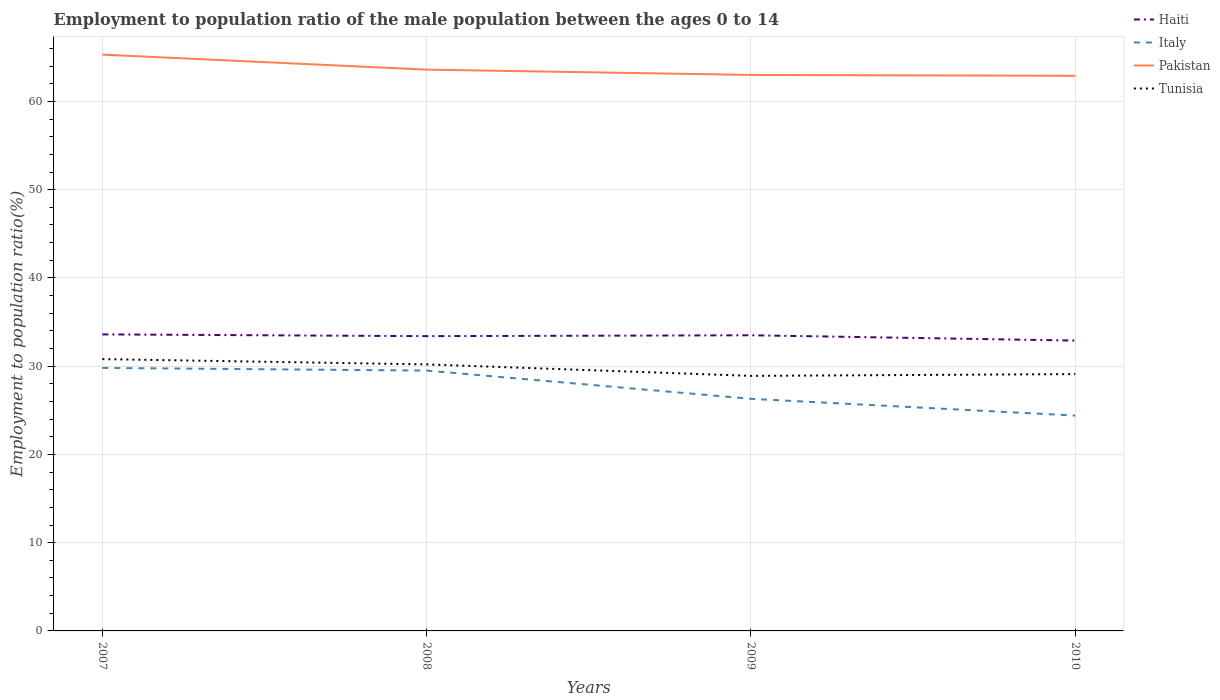Is the number of lines equal to the number of legend labels?
Your answer should be compact. Yes. Across all years, what is the maximum employment to population ratio in Tunisia?
Keep it short and to the point. 28.9. In which year was the employment to population ratio in Tunisia maximum?
Make the answer very short. 2009. What is the total employment to population ratio in Haiti in the graph?
Your answer should be compact. 0.7. What is the difference between the highest and the second highest employment to population ratio in Italy?
Give a very brief answer. 5.4. What is the difference between the highest and the lowest employment to population ratio in Haiti?
Your response must be concise. 3. Is the employment to population ratio in Italy strictly greater than the employment to population ratio in Haiti over the years?
Offer a very short reply. Yes. How many lines are there?
Your answer should be very brief. 4. Does the graph contain any zero values?
Offer a terse response. No. Does the graph contain grids?
Offer a very short reply. Yes. Where does the legend appear in the graph?
Keep it short and to the point. Top right. How many legend labels are there?
Give a very brief answer. 4. What is the title of the graph?
Keep it short and to the point. Employment to population ratio of the male population between the ages 0 to 14. Does "Venezuela" appear as one of the legend labels in the graph?
Your response must be concise. No. What is the Employment to population ratio(%) of Haiti in 2007?
Your response must be concise. 33.6. What is the Employment to population ratio(%) of Italy in 2007?
Keep it short and to the point. 29.8. What is the Employment to population ratio(%) of Pakistan in 2007?
Your response must be concise. 65.3. What is the Employment to population ratio(%) in Tunisia in 2007?
Offer a terse response. 30.8. What is the Employment to population ratio(%) of Haiti in 2008?
Your answer should be compact. 33.4. What is the Employment to population ratio(%) of Italy in 2008?
Provide a short and direct response. 29.5. What is the Employment to population ratio(%) of Pakistan in 2008?
Provide a succinct answer. 63.6. What is the Employment to population ratio(%) in Tunisia in 2008?
Your response must be concise. 30.2. What is the Employment to population ratio(%) in Haiti in 2009?
Your response must be concise. 33.5. What is the Employment to population ratio(%) in Italy in 2009?
Provide a short and direct response. 26.3. What is the Employment to population ratio(%) in Tunisia in 2009?
Your answer should be compact. 28.9. What is the Employment to population ratio(%) of Haiti in 2010?
Provide a succinct answer. 32.9. What is the Employment to population ratio(%) of Italy in 2010?
Your response must be concise. 24.4. What is the Employment to population ratio(%) of Pakistan in 2010?
Make the answer very short. 62.9. What is the Employment to population ratio(%) of Tunisia in 2010?
Your answer should be compact. 29.1. Across all years, what is the maximum Employment to population ratio(%) in Haiti?
Provide a short and direct response. 33.6. Across all years, what is the maximum Employment to population ratio(%) of Italy?
Your answer should be compact. 29.8. Across all years, what is the maximum Employment to population ratio(%) of Pakistan?
Your answer should be very brief. 65.3. Across all years, what is the maximum Employment to population ratio(%) in Tunisia?
Provide a short and direct response. 30.8. Across all years, what is the minimum Employment to population ratio(%) in Haiti?
Make the answer very short. 32.9. Across all years, what is the minimum Employment to population ratio(%) of Italy?
Your answer should be compact. 24.4. Across all years, what is the minimum Employment to population ratio(%) in Pakistan?
Your response must be concise. 62.9. Across all years, what is the minimum Employment to population ratio(%) in Tunisia?
Your response must be concise. 28.9. What is the total Employment to population ratio(%) of Haiti in the graph?
Your answer should be very brief. 133.4. What is the total Employment to population ratio(%) of Italy in the graph?
Offer a terse response. 110. What is the total Employment to population ratio(%) of Pakistan in the graph?
Your answer should be compact. 254.8. What is the total Employment to population ratio(%) in Tunisia in the graph?
Ensure brevity in your answer.  119. What is the difference between the Employment to population ratio(%) in Haiti in 2007 and that in 2008?
Provide a short and direct response. 0.2. What is the difference between the Employment to population ratio(%) of Italy in 2007 and that in 2008?
Provide a short and direct response. 0.3. What is the difference between the Employment to population ratio(%) of Pakistan in 2007 and that in 2008?
Ensure brevity in your answer.  1.7. What is the difference between the Employment to population ratio(%) in Haiti in 2007 and that in 2009?
Give a very brief answer. 0.1. What is the difference between the Employment to population ratio(%) in Italy in 2007 and that in 2009?
Offer a very short reply. 3.5. What is the difference between the Employment to population ratio(%) in Tunisia in 2007 and that in 2009?
Your answer should be very brief. 1.9. What is the difference between the Employment to population ratio(%) in Haiti in 2007 and that in 2010?
Offer a terse response. 0.7. What is the difference between the Employment to population ratio(%) of Haiti in 2008 and that in 2009?
Offer a terse response. -0.1. What is the difference between the Employment to population ratio(%) of Italy in 2008 and that in 2009?
Offer a very short reply. 3.2. What is the difference between the Employment to population ratio(%) in Pakistan in 2008 and that in 2009?
Provide a succinct answer. 0.6. What is the difference between the Employment to population ratio(%) of Pakistan in 2008 and that in 2010?
Your answer should be very brief. 0.7. What is the difference between the Employment to population ratio(%) in Haiti in 2009 and that in 2010?
Offer a very short reply. 0.6. What is the difference between the Employment to population ratio(%) of Italy in 2009 and that in 2010?
Offer a very short reply. 1.9. What is the difference between the Employment to population ratio(%) in Italy in 2007 and the Employment to population ratio(%) in Pakistan in 2008?
Your response must be concise. -33.8. What is the difference between the Employment to population ratio(%) of Italy in 2007 and the Employment to population ratio(%) of Tunisia in 2008?
Your answer should be compact. -0.4. What is the difference between the Employment to population ratio(%) of Pakistan in 2007 and the Employment to population ratio(%) of Tunisia in 2008?
Give a very brief answer. 35.1. What is the difference between the Employment to population ratio(%) of Haiti in 2007 and the Employment to population ratio(%) of Pakistan in 2009?
Offer a terse response. -29.4. What is the difference between the Employment to population ratio(%) in Haiti in 2007 and the Employment to population ratio(%) in Tunisia in 2009?
Offer a terse response. 4.7. What is the difference between the Employment to population ratio(%) of Italy in 2007 and the Employment to population ratio(%) of Pakistan in 2009?
Offer a very short reply. -33.2. What is the difference between the Employment to population ratio(%) in Italy in 2007 and the Employment to population ratio(%) in Tunisia in 2009?
Keep it short and to the point. 0.9. What is the difference between the Employment to population ratio(%) of Pakistan in 2007 and the Employment to population ratio(%) of Tunisia in 2009?
Give a very brief answer. 36.4. What is the difference between the Employment to population ratio(%) of Haiti in 2007 and the Employment to population ratio(%) of Pakistan in 2010?
Give a very brief answer. -29.3. What is the difference between the Employment to population ratio(%) in Italy in 2007 and the Employment to population ratio(%) in Pakistan in 2010?
Offer a very short reply. -33.1. What is the difference between the Employment to population ratio(%) of Pakistan in 2007 and the Employment to population ratio(%) of Tunisia in 2010?
Offer a very short reply. 36.2. What is the difference between the Employment to population ratio(%) in Haiti in 2008 and the Employment to population ratio(%) in Pakistan in 2009?
Make the answer very short. -29.6. What is the difference between the Employment to population ratio(%) of Italy in 2008 and the Employment to population ratio(%) of Pakistan in 2009?
Offer a terse response. -33.5. What is the difference between the Employment to population ratio(%) of Pakistan in 2008 and the Employment to population ratio(%) of Tunisia in 2009?
Make the answer very short. 34.7. What is the difference between the Employment to population ratio(%) in Haiti in 2008 and the Employment to population ratio(%) in Pakistan in 2010?
Ensure brevity in your answer.  -29.5. What is the difference between the Employment to population ratio(%) in Italy in 2008 and the Employment to population ratio(%) in Pakistan in 2010?
Provide a short and direct response. -33.4. What is the difference between the Employment to population ratio(%) of Italy in 2008 and the Employment to population ratio(%) of Tunisia in 2010?
Offer a terse response. 0.4. What is the difference between the Employment to population ratio(%) in Pakistan in 2008 and the Employment to population ratio(%) in Tunisia in 2010?
Provide a succinct answer. 34.5. What is the difference between the Employment to population ratio(%) of Haiti in 2009 and the Employment to population ratio(%) of Italy in 2010?
Keep it short and to the point. 9.1. What is the difference between the Employment to population ratio(%) of Haiti in 2009 and the Employment to population ratio(%) of Pakistan in 2010?
Your answer should be compact. -29.4. What is the difference between the Employment to population ratio(%) of Italy in 2009 and the Employment to population ratio(%) of Pakistan in 2010?
Offer a terse response. -36.6. What is the difference between the Employment to population ratio(%) in Italy in 2009 and the Employment to population ratio(%) in Tunisia in 2010?
Give a very brief answer. -2.8. What is the difference between the Employment to population ratio(%) in Pakistan in 2009 and the Employment to population ratio(%) in Tunisia in 2010?
Your response must be concise. 33.9. What is the average Employment to population ratio(%) in Haiti per year?
Keep it short and to the point. 33.35. What is the average Employment to population ratio(%) of Pakistan per year?
Keep it short and to the point. 63.7. What is the average Employment to population ratio(%) in Tunisia per year?
Your response must be concise. 29.75. In the year 2007, what is the difference between the Employment to population ratio(%) of Haiti and Employment to population ratio(%) of Pakistan?
Provide a succinct answer. -31.7. In the year 2007, what is the difference between the Employment to population ratio(%) of Italy and Employment to population ratio(%) of Pakistan?
Offer a terse response. -35.5. In the year 2007, what is the difference between the Employment to population ratio(%) in Italy and Employment to population ratio(%) in Tunisia?
Ensure brevity in your answer.  -1. In the year 2007, what is the difference between the Employment to population ratio(%) of Pakistan and Employment to population ratio(%) of Tunisia?
Offer a very short reply. 34.5. In the year 2008, what is the difference between the Employment to population ratio(%) in Haiti and Employment to population ratio(%) in Italy?
Give a very brief answer. 3.9. In the year 2008, what is the difference between the Employment to population ratio(%) of Haiti and Employment to population ratio(%) of Pakistan?
Provide a short and direct response. -30.2. In the year 2008, what is the difference between the Employment to population ratio(%) of Haiti and Employment to population ratio(%) of Tunisia?
Your answer should be very brief. 3.2. In the year 2008, what is the difference between the Employment to population ratio(%) in Italy and Employment to population ratio(%) in Pakistan?
Your answer should be compact. -34.1. In the year 2008, what is the difference between the Employment to population ratio(%) in Pakistan and Employment to population ratio(%) in Tunisia?
Your answer should be very brief. 33.4. In the year 2009, what is the difference between the Employment to population ratio(%) of Haiti and Employment to population ratio(%) of Pakistan?
Offer a very short reply. -29.5. In the year 2009, what is the difference between the Employment to population ratio(%) in Haiti and Employment to population ratio(%) in Tunisia?
Give a very brief answer. 4.6. In the year 2009, what is the difference between the Employment to population ratio(%) of Italy and Employment to population ratio(%) of Pakistan?
Ensure brevity in your answer.  -36.7. In the year 2009, what is the difference between the Employment to population ratio(%) of Pakistan and Employment to population ratio(%) of Tunisia?
Provide a short and direct response. 34.1. In the year 2010, what is the difference between the Employment to population ratio(%) in Haiti and Employment to population ratio(%) in Italy?
Ensure brevity in your answer.  8.5. In the year 2010, what is the difference between the Employment to population ratio(%) in Haiti and Employment to population ratio(%) in Tunisia?
Provide a succinct answer. 3.8. In the year 2010, what is the difference between the Employment to population ratio(%) in Italy and Employment to population ratio(%) in Pakistan?
Make the answer very short. -38.5. In the year 2010, what is the difference between the Employment to population ratio(%) in Pakistan and Employment to population ratio(%) in Tunisia?
Offer a terse response. 33.8. What is the ratio of the Employment to population ratio(%) of Haiti in 2007 to that in 2008?
Make the answer very short. 1.01. What is the ratio of the Employment to population ratio(%) in Italy in 2007 to that in 2008?
Provide a succinct answer. 1.01. What is the ratio of the Employment to population ratio(%) in Pakistan in 2007 to that in 2008?
Your answer should be very brief. 1.03. What is the ratio of the Employment to population ratio(%) of Tunisia in 2007 to that in 2008?
Offer a very short reply. 1.02. What is the ratio of the Employment to population ratio(%) of Italy in 2007 to that in 2009?
Provide a short and direct response. 1.13. What is the ratio of the Employment to population ratio(%) of Pakistan in 2007 to that in 2009?
Your answer should be compact. 1.04. What is the ratio of the Employment to population ratio(%) in Tunisia in 2007 to that in 2009?
Provide a succinct answer. 1.07. What is the ratio of the Employment to population ratio(%) of Haiti in 2007 to that in 2010?
Provide a short and direct response. 1.02. What is the ratio of the Employment to population ratio(%) in Italy in 2007 to that in 2010?
Ensure brevity in your answer.  1.22. What is the ratio of the Employment to population ratio(%) of Pakistan in 2007 to that in 2010?
Provide a succinct answer. 1.04. What is the ratio of the Employment to population ratio(%) in Tunisia in 2007 to that in 2010?
Make the answer very short. 1.06. What is the ratio of the Employment to population ratio(%) in Italy in 2008 to that in 2009?
Your response must be concise. 1.12. What is the ratio of the Employment to population ratio(%) of Pakistan in 2008 to that in 2009?
Give a very brief answer. 1.01. What is the ratio of the Employment to population ratio(%) in Tunisia in 2008 to that in 2009?
Keep it short and to the point. 1.04. What is the ratio of the Employment to population ratio(%) in Haiti in 2008 to that in 2010?
Make the answer very short. 1.02. What is the ratio of the Employment to population ratio(%) of Italy in 2008 to that in 2010?
Keep it short and to the point. 1.21. What is the ratio of the Employment to population ratio(%) of Pakistan in 2008 to that in 2010?
Provide a short and direct response. 1.01. What is the ratio of the Employment to population ratio(%) of Tunisia in 2008 to that in 2010?
Provide a short and direct response. 1.04. What is the ratio of the Employment to population ratio(%) in Haiti in 2009 to that in 2010?
Give a very brief answer. 1.02. What is the ratio of the Employment to population ratio(%) of Italy in 2009 to that in 2010?
Give a very brief answer. 1.08. What is the ratio of the Employment to population ratio(%) in Pakistan in 2009 to that in 2010?
Give a very brief answer. 1. What is the difference between the highest and the second highest Employment to population ratio(%) of Italy?
Offer a terse response. 0.3. What is the difference between the highest and the lowest Employment to population ratio(%) of Italy?
Your response must be concise. 5.4. What is the difference between the highest and the lowest Employment to population ratio(%) of Pakistan?
Offer a terse response. 2.4. What is the difference between the highest and the lowest Employment to population ratio(%) of Tunisia?
Your answer should be very brief. 1.9. 